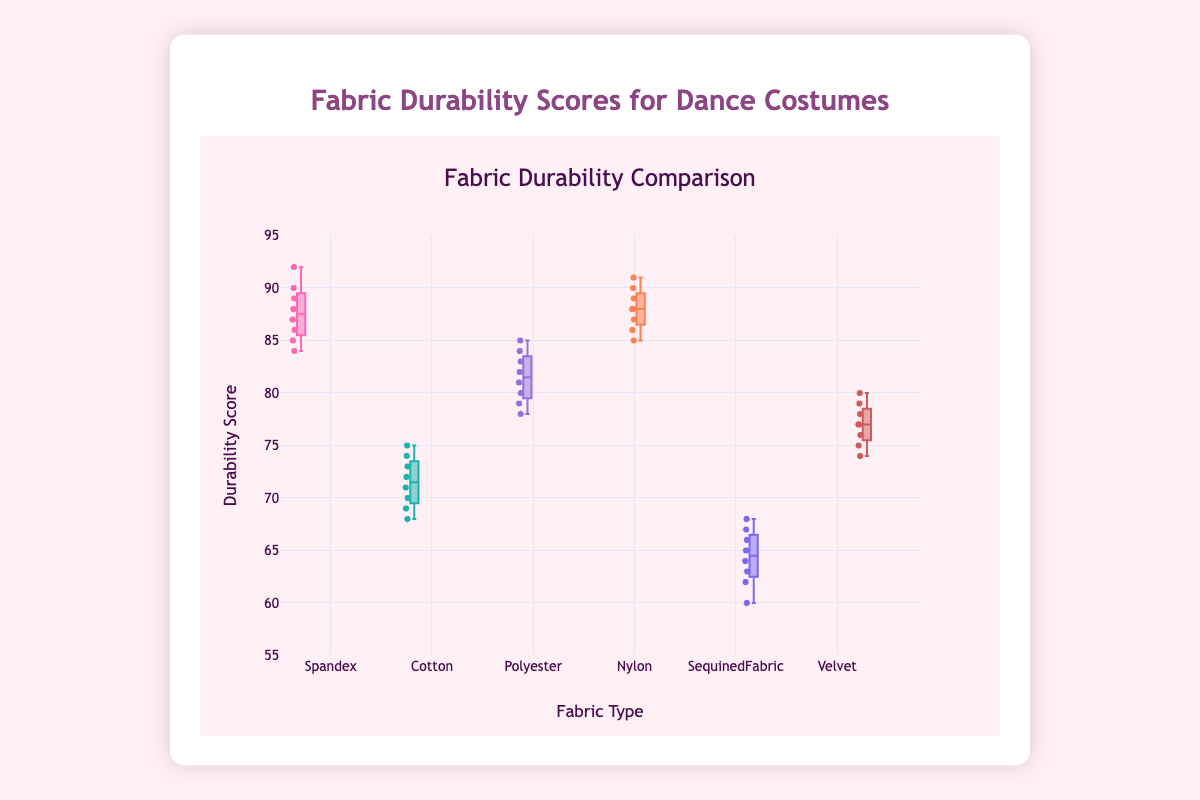How many types of fabric materials are compared in this plot? The plot displays the durability scores for different fabric materials. To find out how many types are compared, we count the number of distinct fabric names on the x-axis.
Answer: 6 Which fabric has the highest median durability score? The highest median durability score is found by looking at the central line inside each box of each fabric type. The fabric with the highest median value in the y-axis is identified.
Answer: Nylon What is the interquartile range (IQR) of Spandex's durability scores? The IQR is calculated by subtracting the first quartile value (Q1) from the third quartile value (Q3) of the Spandex box. These values are the boundaries of the box in the box plot.
Answer: 5 Compare the median durability scores of Cotton and Velvet. Which one is higher? To compare the median durability scores, we look at the central lines inside the boxes for Cotton and Velvet. The fabric with the higher central line has the higher median score.
Answer: Velvet Which fabric has the greatest spread in durability scores? The spread of scores is indicated by the length of the box and the whiskers. The fabric with the longest box and whiskers combined shows the greatest spread.
Answer: Polyester What is the range of durability scores for Sequined Fabric? The range is determined by finding the difference between the maximum and minimum values (whiskers) for Sequined Fabric.
Answer: 8 Which fabric has the lowest lower quartile (Q1) value? The lower quartile value is represented by the bottom edge of the box for each fabric. The fabric with the lowest bottom edge has the lowest Q1 value.
Answer: Sequined Fabric How do the maximum durability scores of Spandex and Velvet compare? To compare the maximum values, we look at the top whiskers for Spandex and Velvet. The fabric with the higher whisker has the higher maximum score.
Answer: Spandex What is the median durability score for Polyester? The median is indicated by the line inside the box for Polyester. We find the y-axis value where this line is positioned.
Answer: 82.5 Is there any overlap in the interquartile ranges (IQRs) of Nylon and Spandex? To check for overlap, we look at the boxes of Nylon and Spandex. If the top edge of one box is lower than the bottom edge of the other, there is no overlap. Otherwise, they overlap.
Answer: Yes 